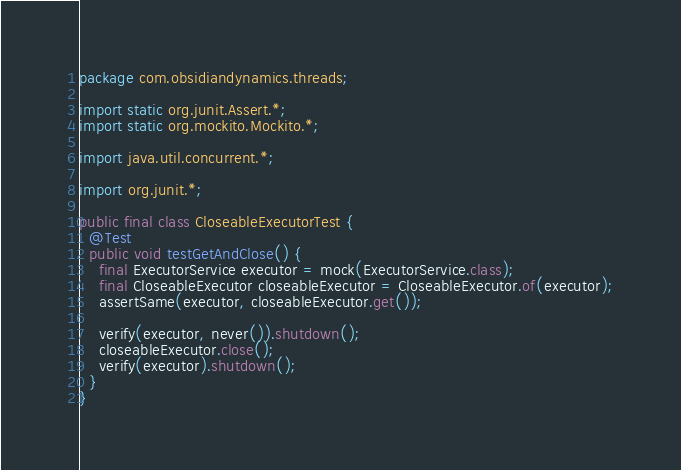<code> <loc_0><loc_0><loc_500><loc_500><_Java_>package com.obsidiandynamics.threads;

import static org.junit.Assert.*;
import static org.mockito.Mockito.*;

import java.util.concurrent.*;

import org.junit.*;

public final class CloseableExecutorTest {
  @Test
  public void testGetAndClose() {
    final ExecutorService executor = mock(ExecutorService.class);
    final CloseableExecutor closeableExecutor = CloseableExecutor.of(executor);
    assertSame(executor, closeableExecutor.get());
    
    verify(executor, never()).shutdown();
    closeableExecutor.close();
    verify(executor).shutdown();
  }
}
</code> 